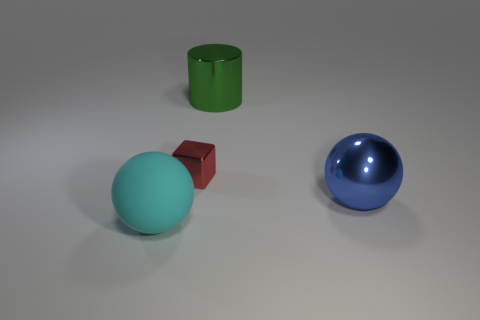Add 4 big red shiny cubes. How many objects exist? 8 Subtract all blocks. How many objects are left? 3 Add 2 red shiny blocks. How many red shiny blocks are left? 3 Add 3 blocks. How many blocks exist? 4 Subtract 0 cyan cylinders. How many objects are left? 4 Subtract all red cubes. Subtract all green shiny things. How many objects are left? 2 